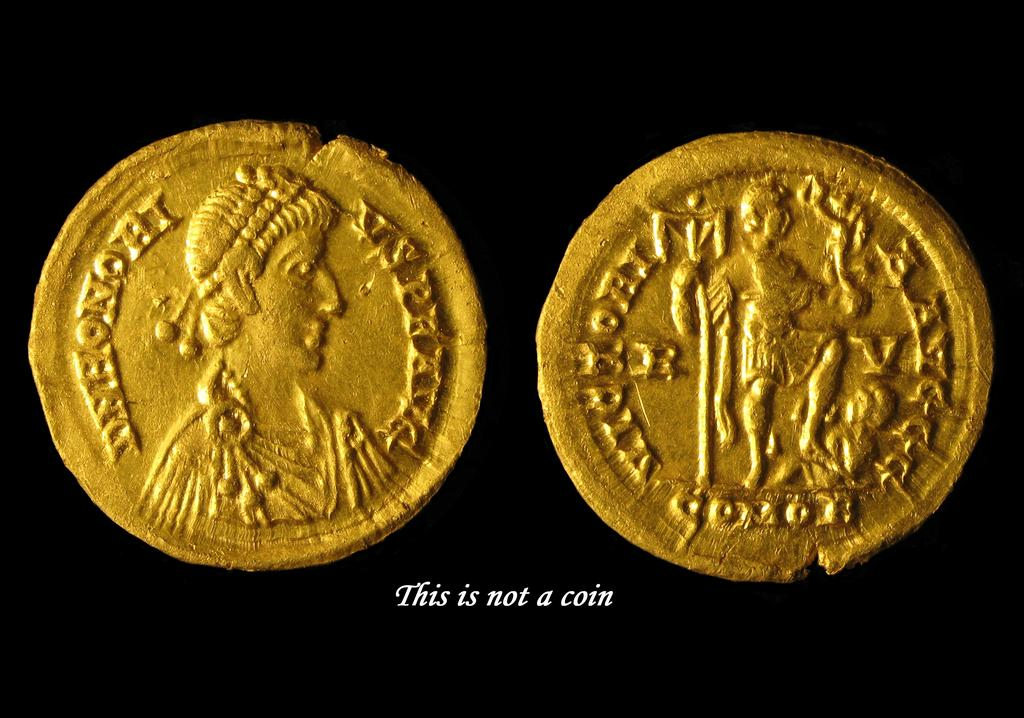<image>
Present a compact description of the photo's key features. Two golden circles with inscriptions above  letters saying This is not a coin. 